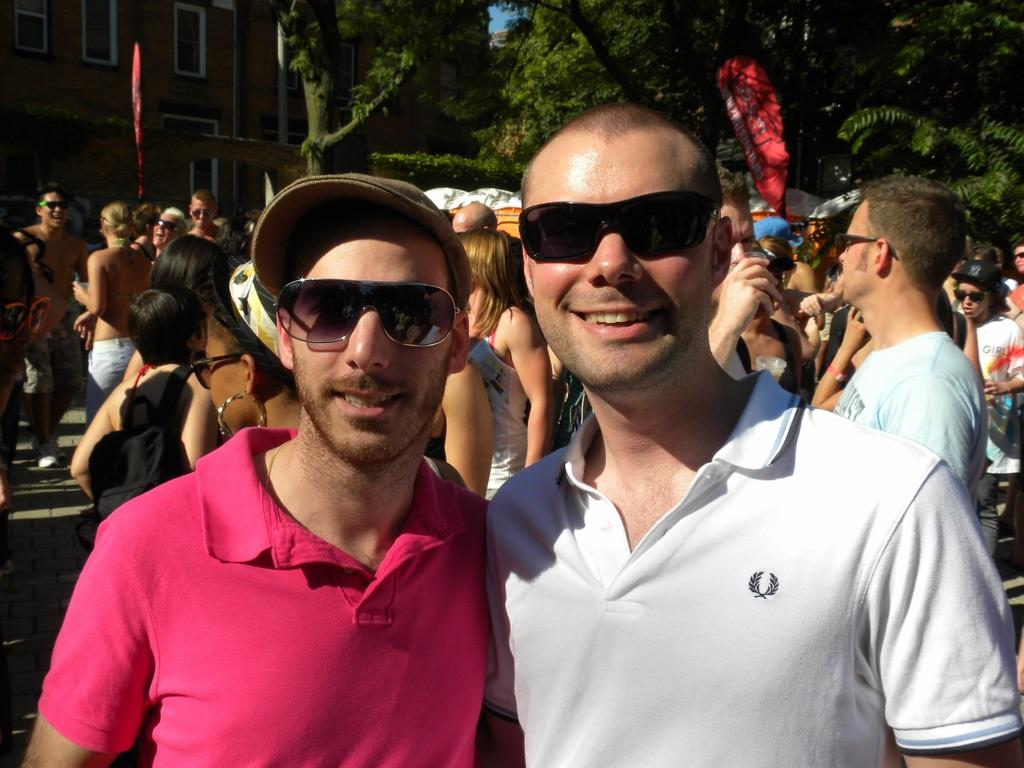What can be observed about the people in the image? There are people standing in the image, and two of them are standing in front and wearing sunglasses. What can be seen in the background of the image? There are trees and a building visible in the background. What type of desk is visible in the image? There is no desk present in the image. What appliance can be seen in the hands of the people in the image? There is no appliance visible in the hands of the people in the image. 